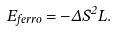Convert formula to latex. <formula><loc_0><loc_0><loc_500><loc_500>E _ { f e r r o } = - \Delta S ^ { 2 } L .</formula> 